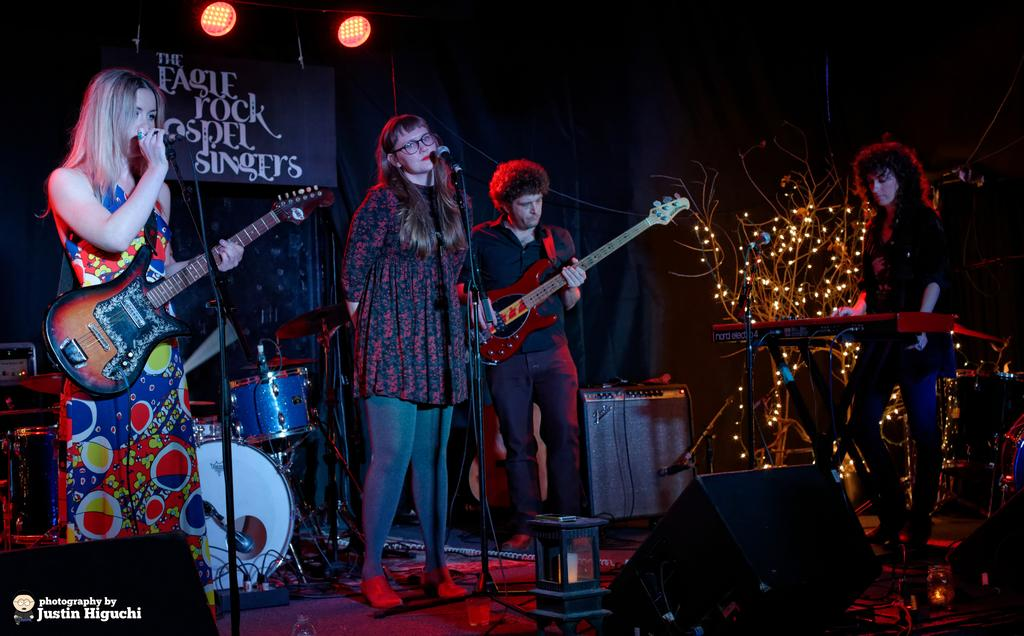What type of event is taking place in the image? A rock band is performing in an event. How many members are in the band? The band consists of three women and a man. What type of scarecrow is standing near the band in the image? There is no scarecrow present in the image; it features a rock band performing. What type of ship can be seen sailing in the background of the image? There is no ship visible in the image; it focuses on the rock band performing. 